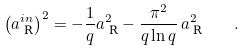Convert formula to latex. <formula><loc_0><loc_0><loc_500><loc_500>\left ( a ^ { i n } _ { \text { R} } \right ) ^ { 2 } = - \frac { 1 } { q } a _ { \text { R} } ^ { 2 } - \frac { \pi ^ { 2 } } { q \ln q } \, a _ { \text { R} } ^ { 2 } \quad .</formula> 